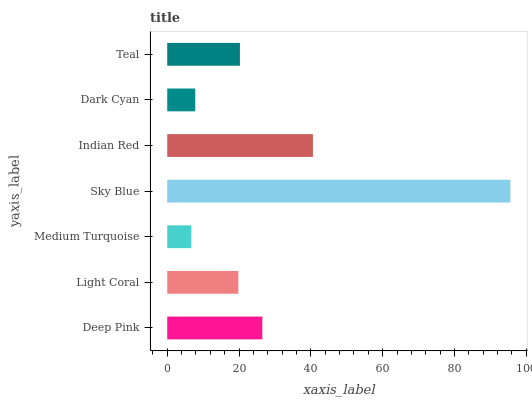Is Medium Turquoise the minimum?
Answer yes or no. Yes. Is Sky Blue the maximum?
Answer yes or no. Yes. Is Light Coral the minimum?
Answer yes or no. No. Is Light Coral the maximum?
Answer yes or no. No. Is Deep Pink greater than Light Coral?
Answer yes or no. Yes. Is Light Coral less than Deep Pink?
Answer yes or no. Yes. Is Light Coral greater than Deep Pink?
Answer yes or no. No. Is Deep Pink less than Light Coral?
Answer yes or no. No. Is Teal the high median?
Answer yes or no. Yes. Is Teal the low median?
Answer yes or no. Yes. Is Sky Blue the high median?
Answer yes or no. No. Is Light Coral the low median?
Answer yes or no. No. 